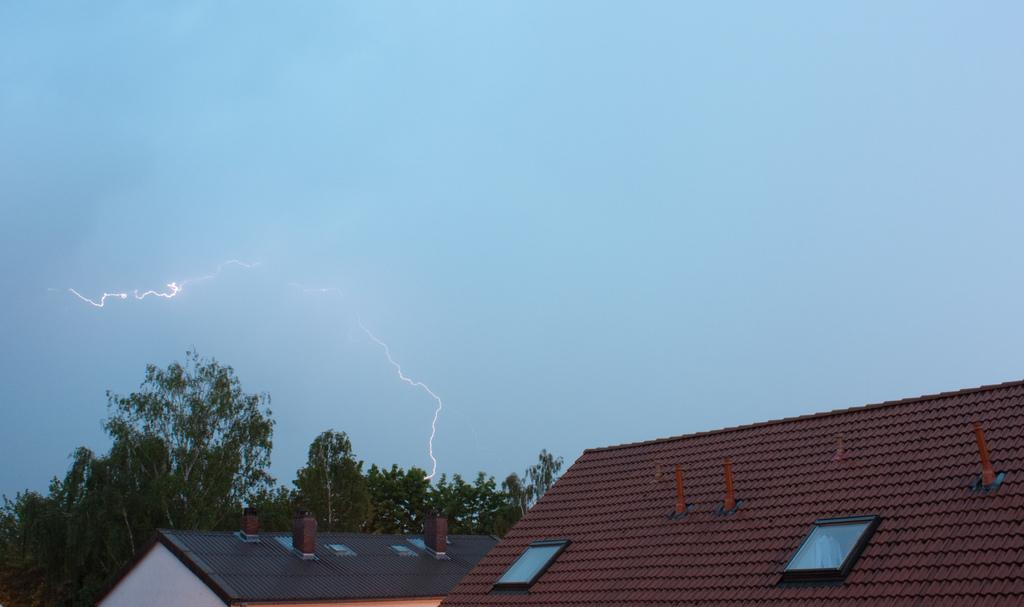What structures are visible in the image? There are roofs of 2 buildings in the image. What type of vegetation can be seen in the image? There are trees at the back of the image. What weather condition is depicted in the image? There is thunder in the sky in the image. What type of leather material is used for the roof of the buildings in the image? There is no mention of leather material in the image; the roofs are not described in detail. 